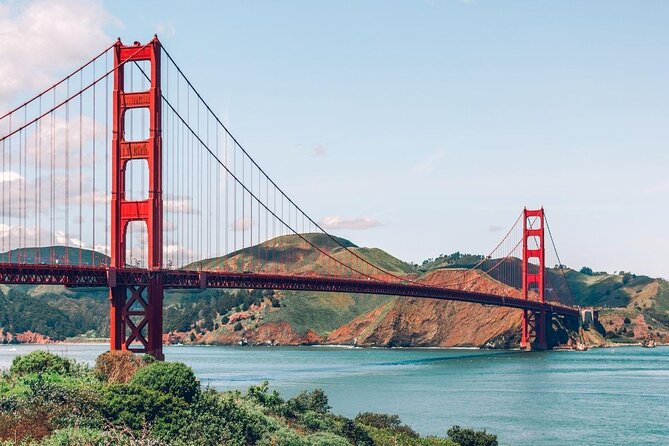Imagine if the Golden Gate Bridge could talk. What stories do you think it would tell? If the Golden Gate Bridge could talk, it would certainly have a wealth of stories to share. It might recount the excitement and challenges of its construction during the Great Depression, the countless sunrises and sunsets it has witnessed, and the daily hustle of commuters and tourists. The bridge could also speak of the resilience it showed during earthquakes, the silent nights where it stands majestically under the starry sky, and the moments it shared with all those who have crossed it, from everyday workers to daredevil climbers. 